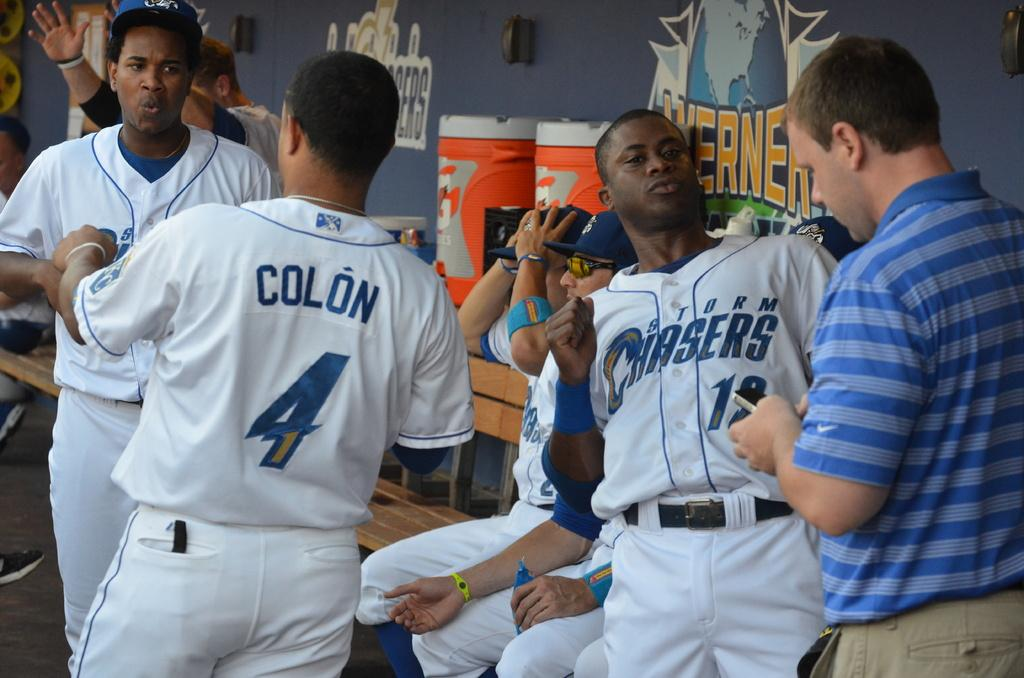<image>
Summarize the visual content of the image. A man in a blue striped shirt is texting on his phone while in the Storm Chaser's dug out. 